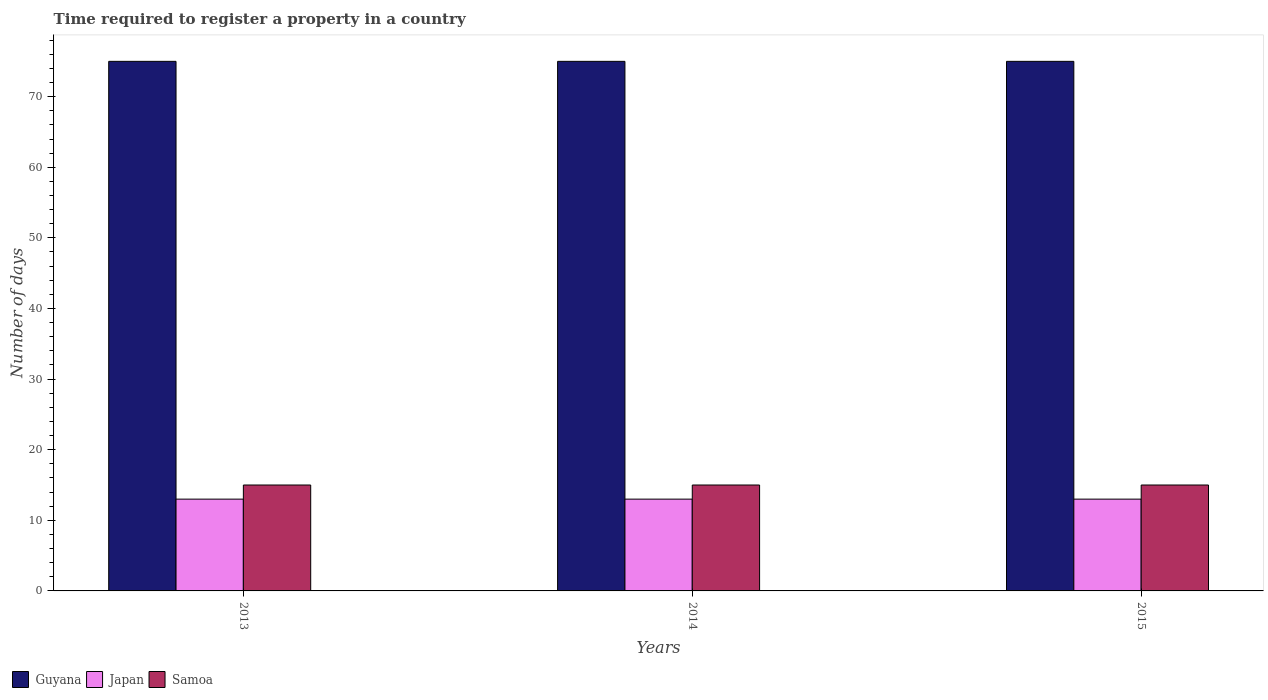How many different coloured bars are there?
Your response must be concise. 3. How many groups of bars are there?
Provide a succinct answer. 3. How many bars are there on the 3rd tick from the left?
Make the answer very short. 3. In how many cases, is the number of bars for a given year not equal to the number of legend labels?
Your response must be concise. 0. What is the number of days required to register a property in Samoa in 2013?
Your answer should be very brief. 15. Across all years, what is the maximum number of days required to register a property in Samoa?
Give a very brief answer. 15. Across all years, what is the minimum number of days required to register a property in Japan?
Your answer should be compact. 13. In which year was the number of days required to register a property in Samoa maximum?
Your response must be concise. 2013. In which year was the number of days required to register a property in Guyana minimum?
Provide a succinct answer. 2013. What is the total number of days required to register a property in Japan in the graph?
Keep it short and to the point. 39. What is the difference between the number of days required to register a property in Samoa in 2014 and that in 2015?
Keep it short and to the point. 0. What is the difference between the number of days required to register a property in Japan in 2015 and the number of days required to register a property in Samoa in 2014?
Offer a very short reply. -2. In the year 2015, what is the difference between the number of days required to register a property in Guyana and number of days required to register a property in Samoa?
Provide a short and direct response. 60. What is the ratio of the number of days required to register a property in Samoa in 2014 to that in 2015?
Give a very brief answer. 1. Is the difference between the number of days required to register a property in Guyana in 2013 and 2014 greater than the difference between the number of days required to register a property in Samoa in 2013 and 2014?
Keep it short and to the point. No. What is the difference between the highest and the second highest number of days required to register a property in Samoa?
Offer a very short reply. 0. In how many years, is the number of days required to register a property in Guyana greater than the average number of days required to register a property in Guyana taken over all years?
Offer a very short reply. 0. What does the 2nd bar from the left in 2015 represents?
Offer a very short reply. Japan. What does the 1st bar from the right in 2013 represents?
Provide a short and direct response. Samoa. Is it the case that in every year, the sum of the number of days required to register a property in Japan and number of days required to register a property in Guyana is greater than the number of days required to register a property in Samoa?
Provide a short and direct response. Yes. How many years are there in the graph?
Offer a very short reply. 3. What is the difference between two consecutive major ticks on the Y-axis?
Offer a very short reply. 10. Does the graph contain any zero values?
Your response must be concise. No. Where does the legend appear in the graph?
Your answer should be compact. Bottom left. How are the legend labels stacked?
Offer a terse response. Horizontal. What is the title of the graph?
Provide a succinct answer. Time required to register a property in a country. What is the label or title of the Y-axis?
Offer a very short reply. Number of days. What is the Number of days in Japan in 2013?
Your response must be concise. 13. What is the Number of days of Guyana in 2014?
Give a very brief answer. 75. What is the Number of days in Japan in 2014?
Offer a terse response. 13. What is the Number of days of Samoa in 2014?
Provide a succinct answer. 15. What is the Number of days of Guyana in 2015?
Your response must be concise. 75. What is the Number of days in Japan in 2015?
Keep it short and to the point. 13. Across all years, what is the maximum Number of days of Japan?
Offer a very short reply. 13. Across all years, what is the maximum Number of days in Samoa?
Give a very brief answer. 15. Across all years, what is the minimum Number of days of Guyana?
Provide a short and direct response. 75. Across all years, what is the minimum Number of days of Japan?
Provide a succinct answer. 13. Across all years, what is the minimum Number of days in Samoa?
Give a very brief answer. 15. What is the total Number of days in Guyana in the graph?
Provide a short and direct response. 225. What is the total Number of days of Samoa in the graph?
Provide a succinct answer. 45. What is the difference between the Number of days of Japan in 2013 and that in 2014?
Offer a very short reply. 0. What is the difference between the Number of days in Samoa in 2013 and that in 2014?
Your answer should be compact. 0. What is the difference between the Number of days in Guyana in 2014 and that in 2015?
Provide a short and direct response. 0. What is the difference between the Number of days in Japan in 2014 and that in 2015?
Keep it short and to the point. 0. What is the difference between the Number of days of Samoa in 2014 and that in 2015?
Provide a succinct answer. 0. What is the difference between the Number of days in Guyana in 2013 and the Number of days in Japan in 2014?
Provide a succinct answer. 62. What is the difference between the Number of days of Japan in 2013 and the Number of days of Samoa in 2014?
Keep it short and to the point. -2. What is the difference between the Number of days in Guyana in 2013 and the Number of days in Japan in 2015?
Your answer should be very brief. 62. What is the difference between the Number of days of Guyana in 2013 and the Number of days of Samoa in 2015?
Offer a very short reply. 60. What is the difference between the Number of days of Guyana in 2014 and the Number of days of Japan in 2015?
Your response must be concise. 62. What is the average Number of days of Guyana per year?
Your answer should be compact. 75. What is the average Number of days of Japan per year?
Offer a terse response. 13. In the year 2014, what is the difference between the Number of days of Guyana and Number of days of Samoa?
Keep it short and to the point. 60. In the year 2015, what is the difference between the Number of days in Guyana and Number of days in Japan?
Provide a succinct answer. 62. What is the ratio of the Number of days in Japan in 2013 to that in 2014?
Offer a terse response. 1. What is the ratio of the Number of days of Samoa in 2013 to that in 2014?
Offer a terse response. 1. What is the ratio of the Number of days in Japan in 2013 to that in 2015?
Keep it short and to the point. 1. What is the ratio of the Number of days of Japan in 2014 to that in 2015?
Provide a short and direct response. 1. What is the difference between the highest and the second highest Number of days in Samoa?
Your response must be concise. 0. What is the difference between the highest and the lowest Number of days in Guyana?
Offer a terse response. 0. What is the difference between the highest and the lowest Number of days in Japan?
Your answer should be very brief. 0. 